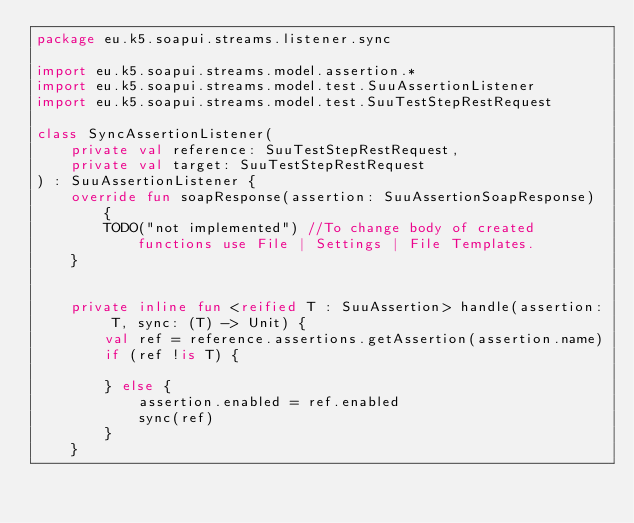<code> <loc_0><loc_0><loc_500><loc_500><_Kotlin_>package eu.k5.soapui.streams.listener.sync

import eu.k5.soapui.streams.model.assertion.*
import eu.k5.soapui.streams.model.test.SuuAssertionListener
import eu.k5.soapui.streams.model.test.SuuTestStepRestRequest

class SyncAssertionListener(
    private val reference: SuuTestStepRestRequest,
    private val target: SuuTestStepRestRequest
) : SuuAssertionListener {
    override fun soapResponse(assertion: SuuAssertionSoapResponse) {
        TODO("not implemented") //To change body of created functions use File | Settings | File Templates.
    }


    private inline fun <reified T : SuuAssertion> handle(assertion: T, sync: (T) -> Unit) {
        val ref = reference.assertions.getAssertion(assertion.name)
        if (ref !is T) {

        } else {
            assertion.enabled = ref.enabled
            sync(ref)
        }
    }
</code> 